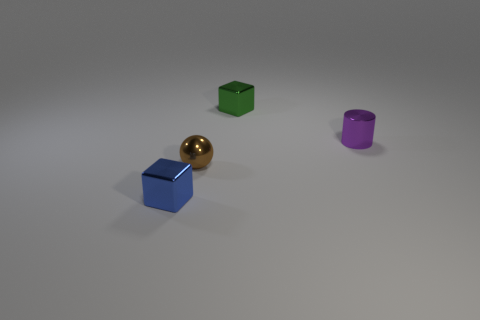Add 2 blue metallic things. How many objects exist? 6 Subtract all cylinders. How many objects are left? 3 Subtract 0 yellow cylinders. How many objects are left? 4 Subtract all yellow blocks. Subtract all gray spheres. How many blocks are left? 2 Subtract all small brown shiny spheres. Subtract all purple cylinders. How many objects are left? 2 Add 4 small purple shiny cylinders. How many small purple shiny cylinders are left? 5 Add 1 blue cubes. How many blue cubes exist? 2 